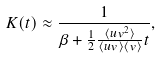<formula> <loc_0><loc_0><loc_500><loc_500>K ( t ) \approx \frac { 1 } { \beta + \frac { 1 } { 2 } \frac { \langle u v ^ { 2 } \rangle } { \langle u v \rangle \langle v \rangle } t } ,</formula> 